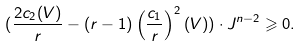Convert formula to latex. <formula><loc_0><loc_0><loc_500><loc_500>( \frac { 2 c _ { 2 } ( V ) } { r } - ( r - 1 ) \left ( \frac { c _ { 1 } } { r } \right ) ^ { 2 } ( V ) ) \cdot J ^ { n - 2 } \geqslant 0 .</formula> 